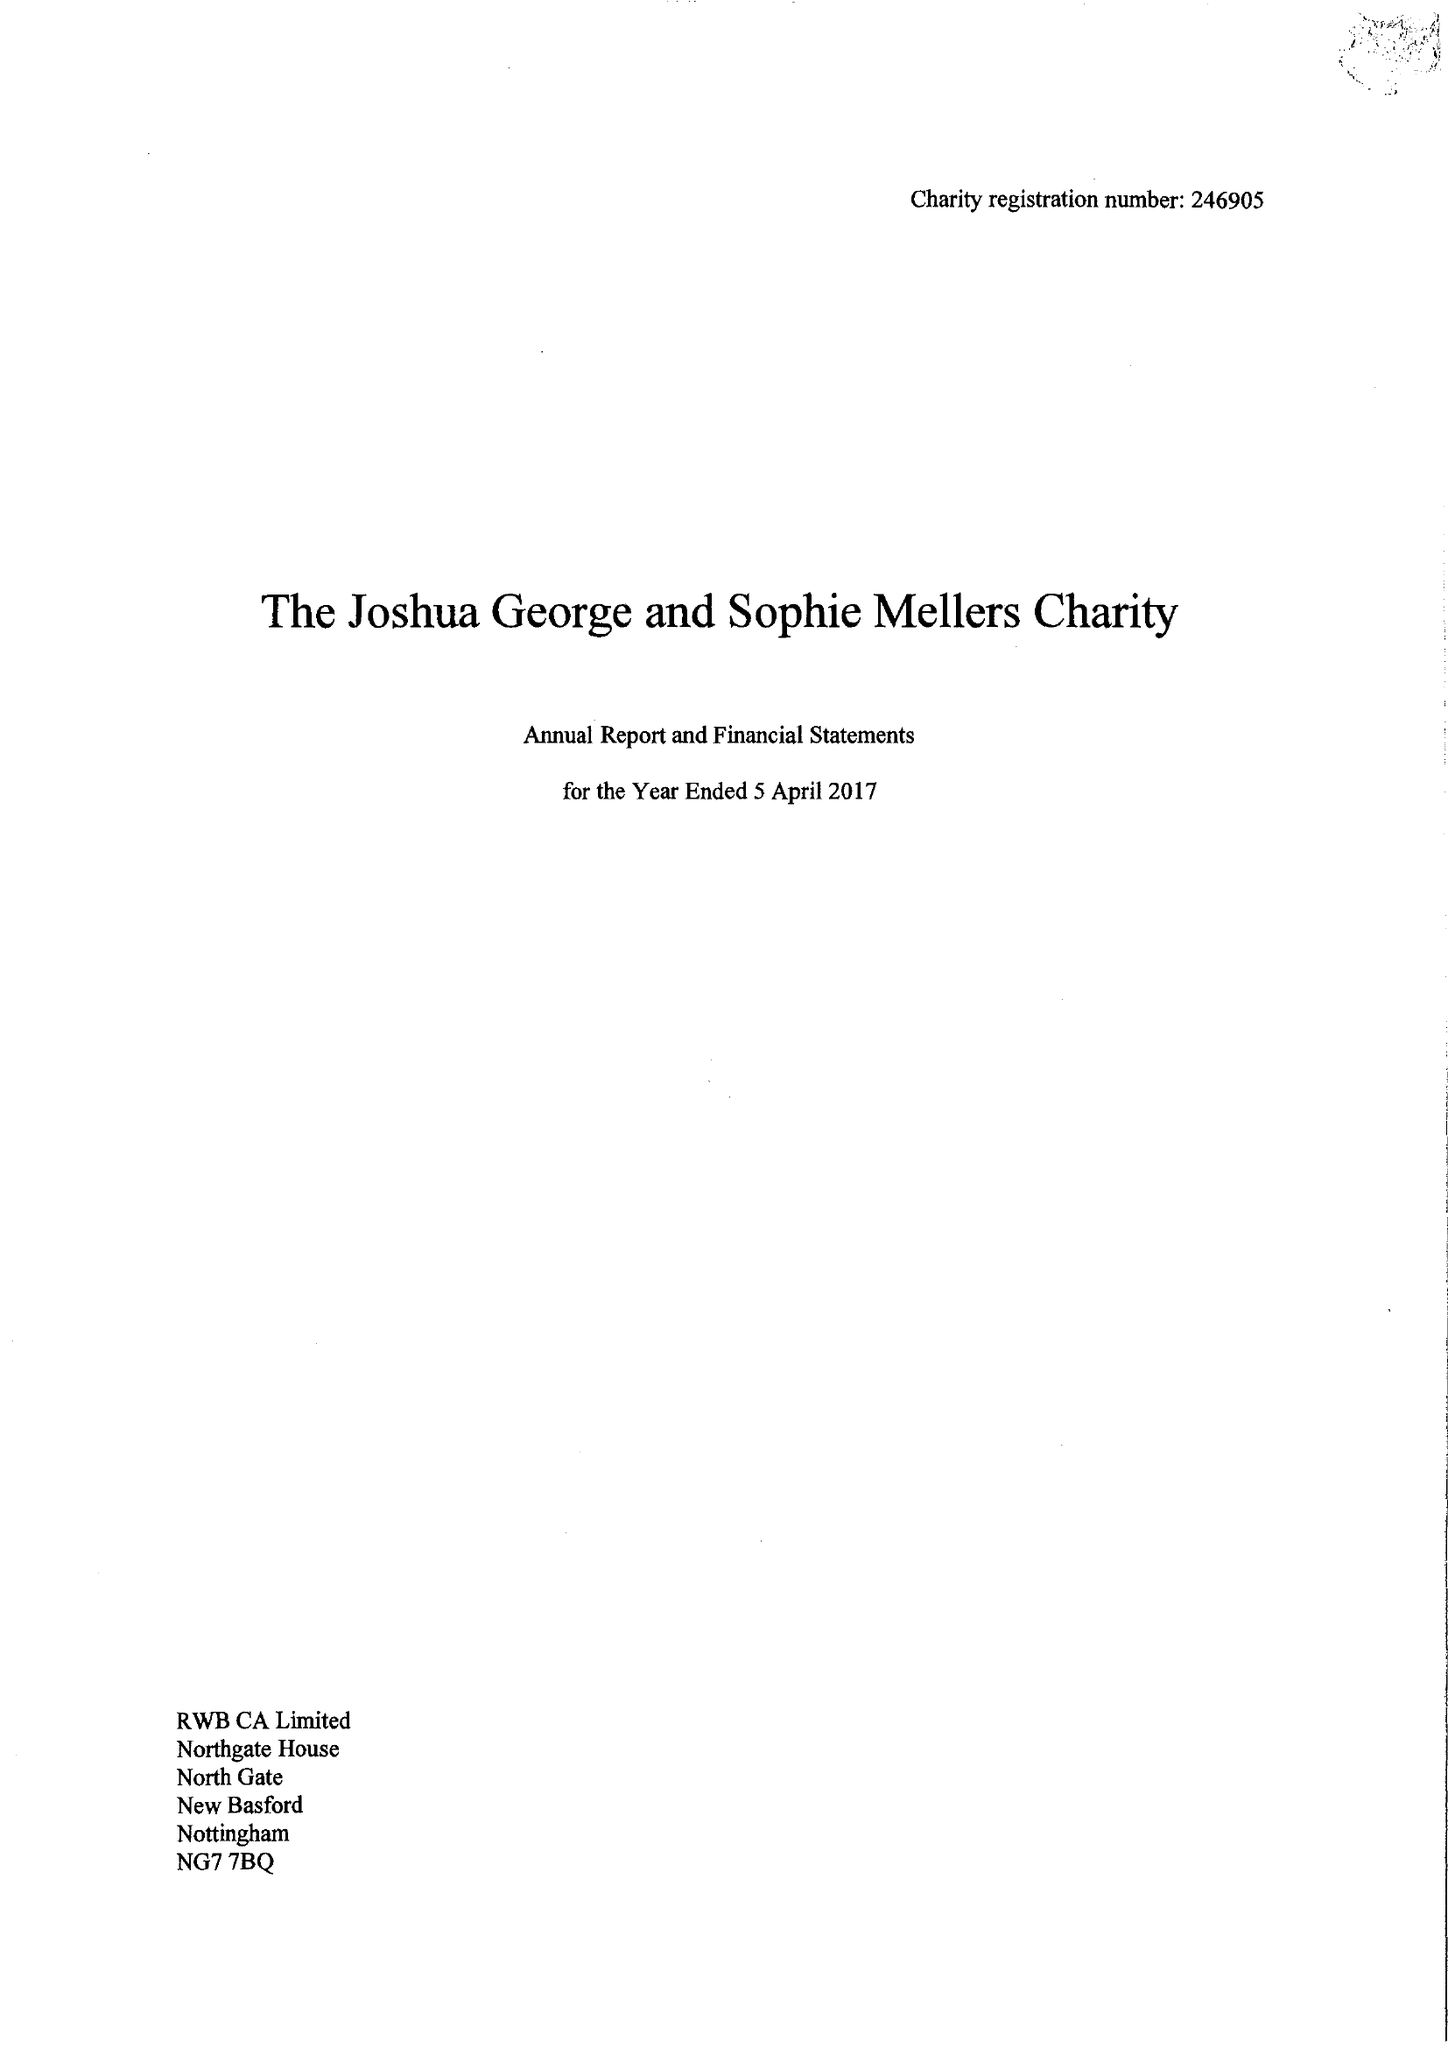What is the value for the charity_number?
Answer the question using a single word or phrase. 246905 